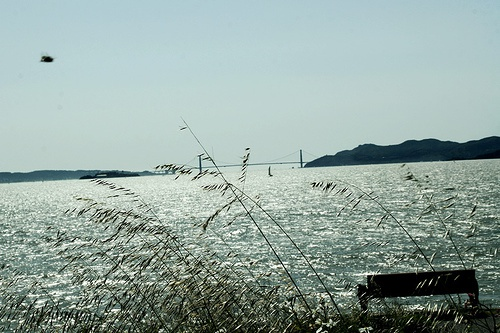Describe the objects in this image and their specific colors. I can see bench in lightblue, black, gray, and darkgreen tones, airplane in lightblue, black, teal, and darkgray tones, and boat in lightblue, black, darkgray, gray, and darkgreen tones in this image. 